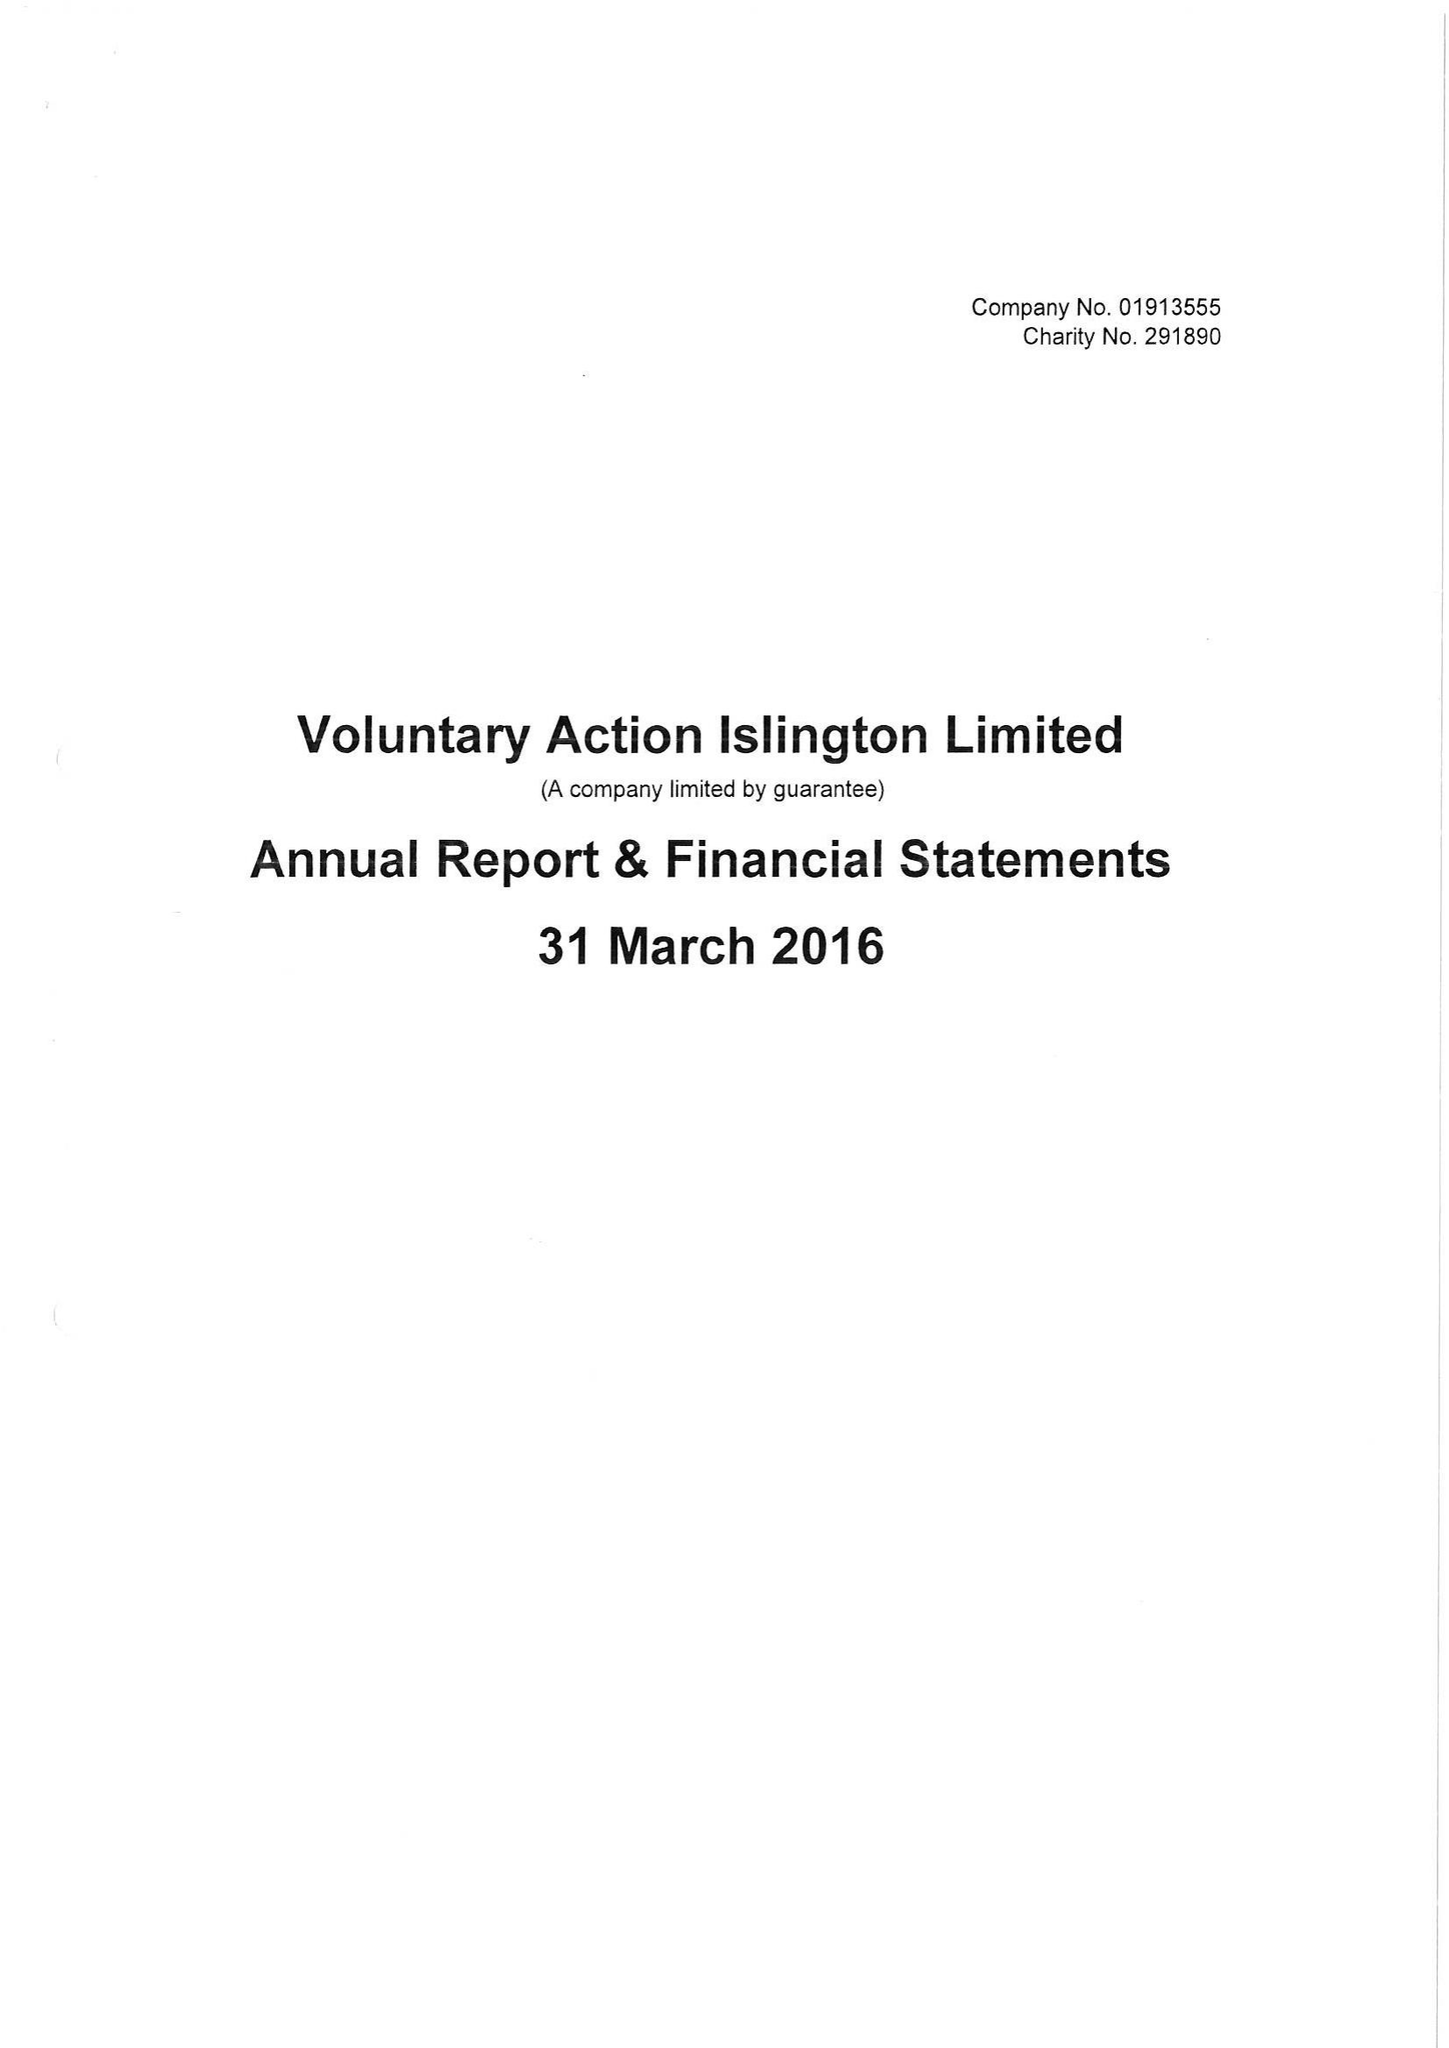What is the value for the report_date?
Answer the question using a single word or phrase. 2016-03-31 